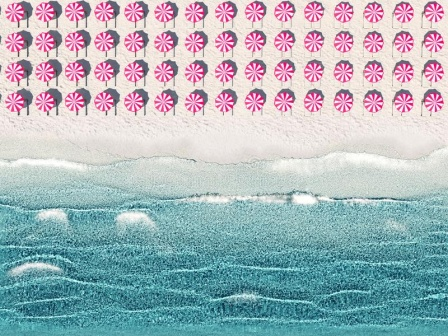Can you create a longer and more detailed realistic scenario for this beach scene? Certainly! On a bright summer morning, the Thompson family decides to spend their day at 'Peppermint Drift Beach.' They arrive with their car loaded with beach gear, excited for a day of relaxation and fun. The children, Max and Lily, immediately notice the sky filled with rows of candy-like clouds and squeal in delight, running ahead to pick the perfect spot on the expansive sandy shore. Mr. Thompson sets up a large beach umbrella patterned in pink and white, harmonizing with the surreal sky, while Mrs. Thompson lays out their picnic blanket on the textured, beige sand that sparkles subtly under the sunlight. As the parents relax with their books, Max builds a sprawling sandcastle with intricate turrets and an encircling moat, showing remarkable creativity. Lily collects seashells washed ashore by the rhythmic waves, marveling at their beauty. Occasionally, she dips her toes in the cool, wavy blue water, giggling when the foam swirls around her ankles. The family takes a break for a picnic, enjoying sandwiches, fresh fruit, and cold lemonade, their laughter blending with the soft roar of the ocean. After lunch, they play a game of beach volleyball, their movements energetic against the serene backdrop of the ocean. As the day progresses, they are joined by friends, and together they create memories filled with joy and togetherness, perfectly complementing the tranquil and imaginative beauty of the beach. 